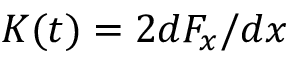Convert formula to latex. <formula><loc_0><loc_0><loc_500><loc_500>K ( t ) = 2 d F _ { x } / d x</formula> 